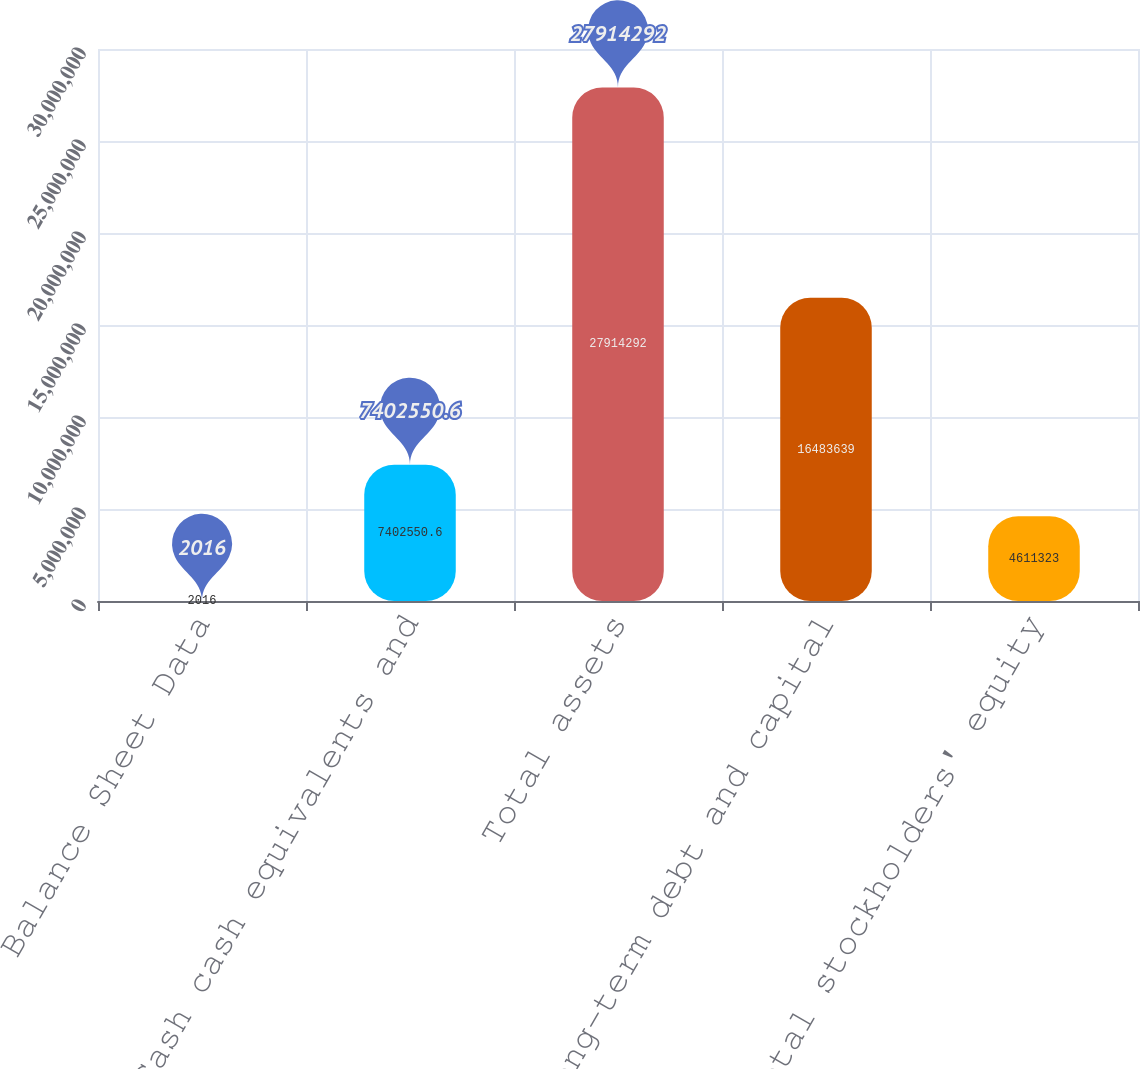Convert chart. <chart><loc_0><loc_0><loc_500><loc_500><bar_chart><fcel>Balance Sheet Data<fcel>Cash cash equivalents and<fcel>Total assets<fcel>Long-term debt and capital<fcel>Total stockholders' equity<nl><fcel>2016<fcel>7.40255e+06<fcel>2.79143e+07<fcel>1.64836e+07<fcel>4.61132e+06<nl></chart> 